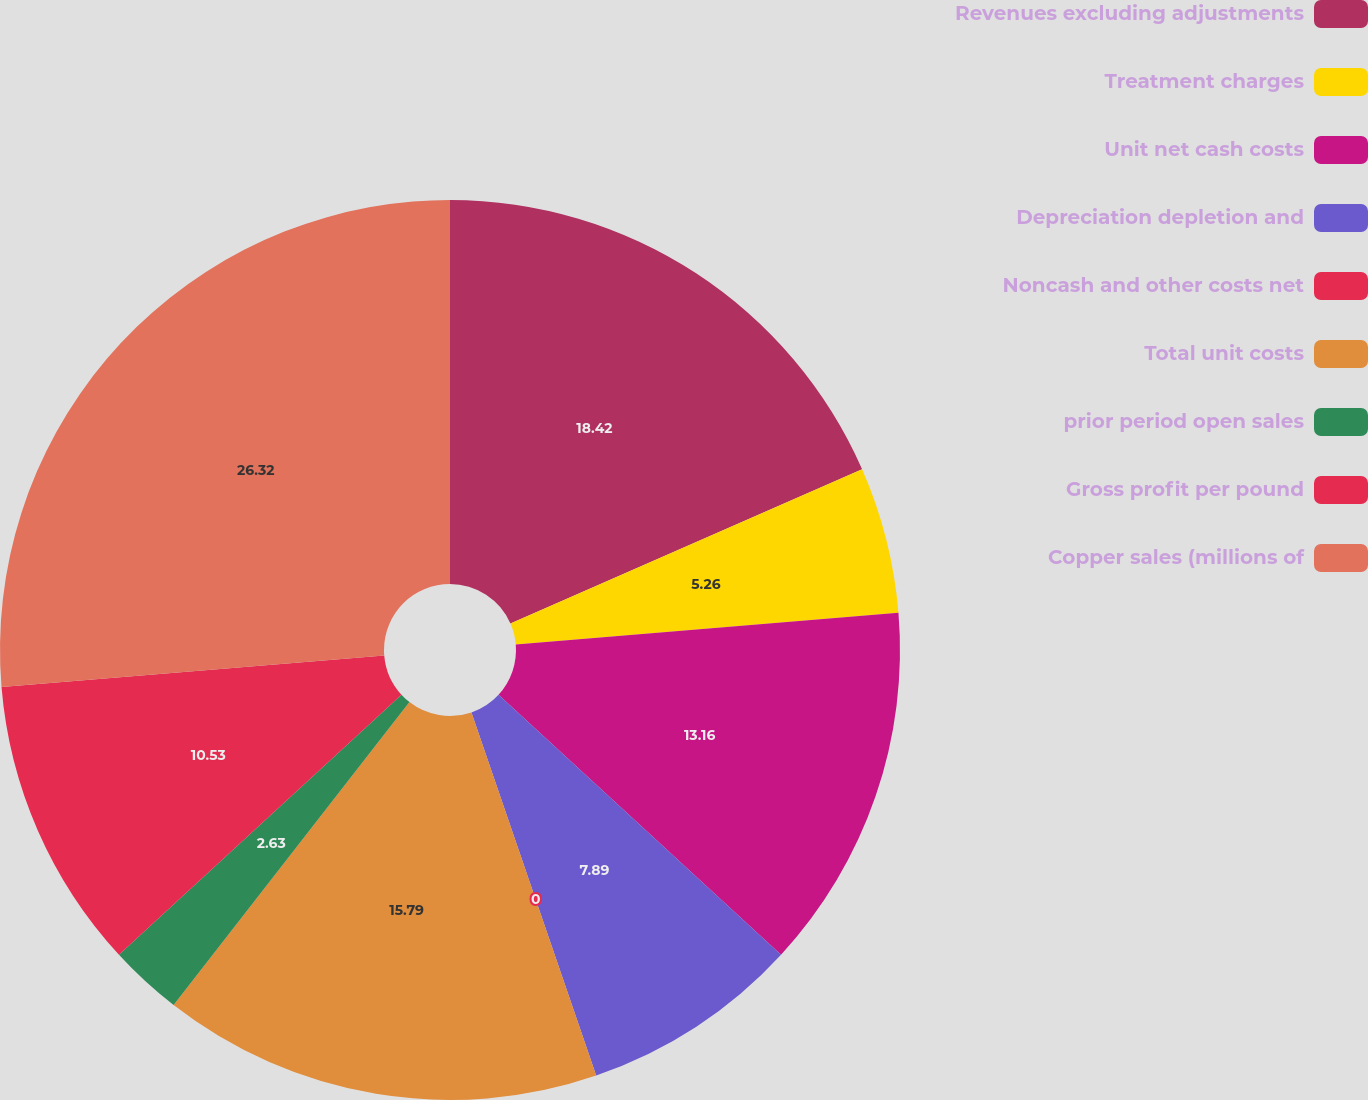Convert chart. <chart><loc_0><loc_0><loc_500><loc_500><pie_chart><fcel>Revenues excluding adjustments<fcel>Treatment charges<fcel>Unit net cash costs<fcel>Depreciation depletion and<fcel>Noncash and other costs net<fcel>Total unit costs<fcel>prior period open sales<fcel>Gross profit per pound<fcel>Copper sales (millions of<nl><fcel>18.42%<fcel>5.26%<fcel>13.16%<fcel>7.89%<fcel>0.0%<fcel>15.79%<fcel>2.63%<fcel>10.53%<fcel>26.31%<nl></chart> 